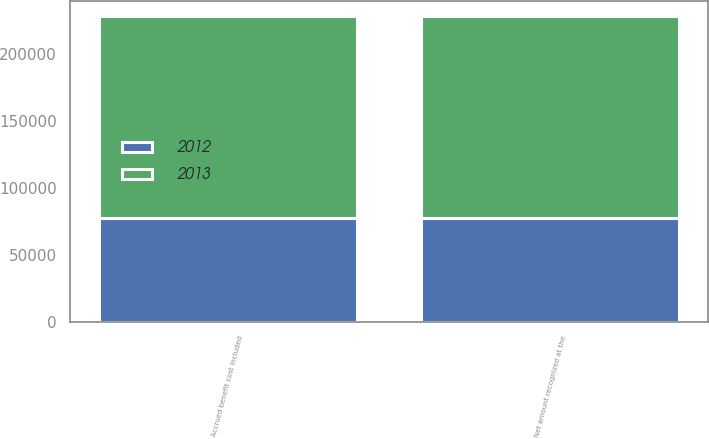<chart> <loc_0><loc_0><loc_500><loc_500><stacked_bar_chart><ecel><fcel>Accrued benefit cost included<fcel>Net amount recognized at the<nl><fcel>2012<fcel>77662<fcel>77662<nl><fcel>2013<fcel>150257<fcel>150257<nl></chart> 